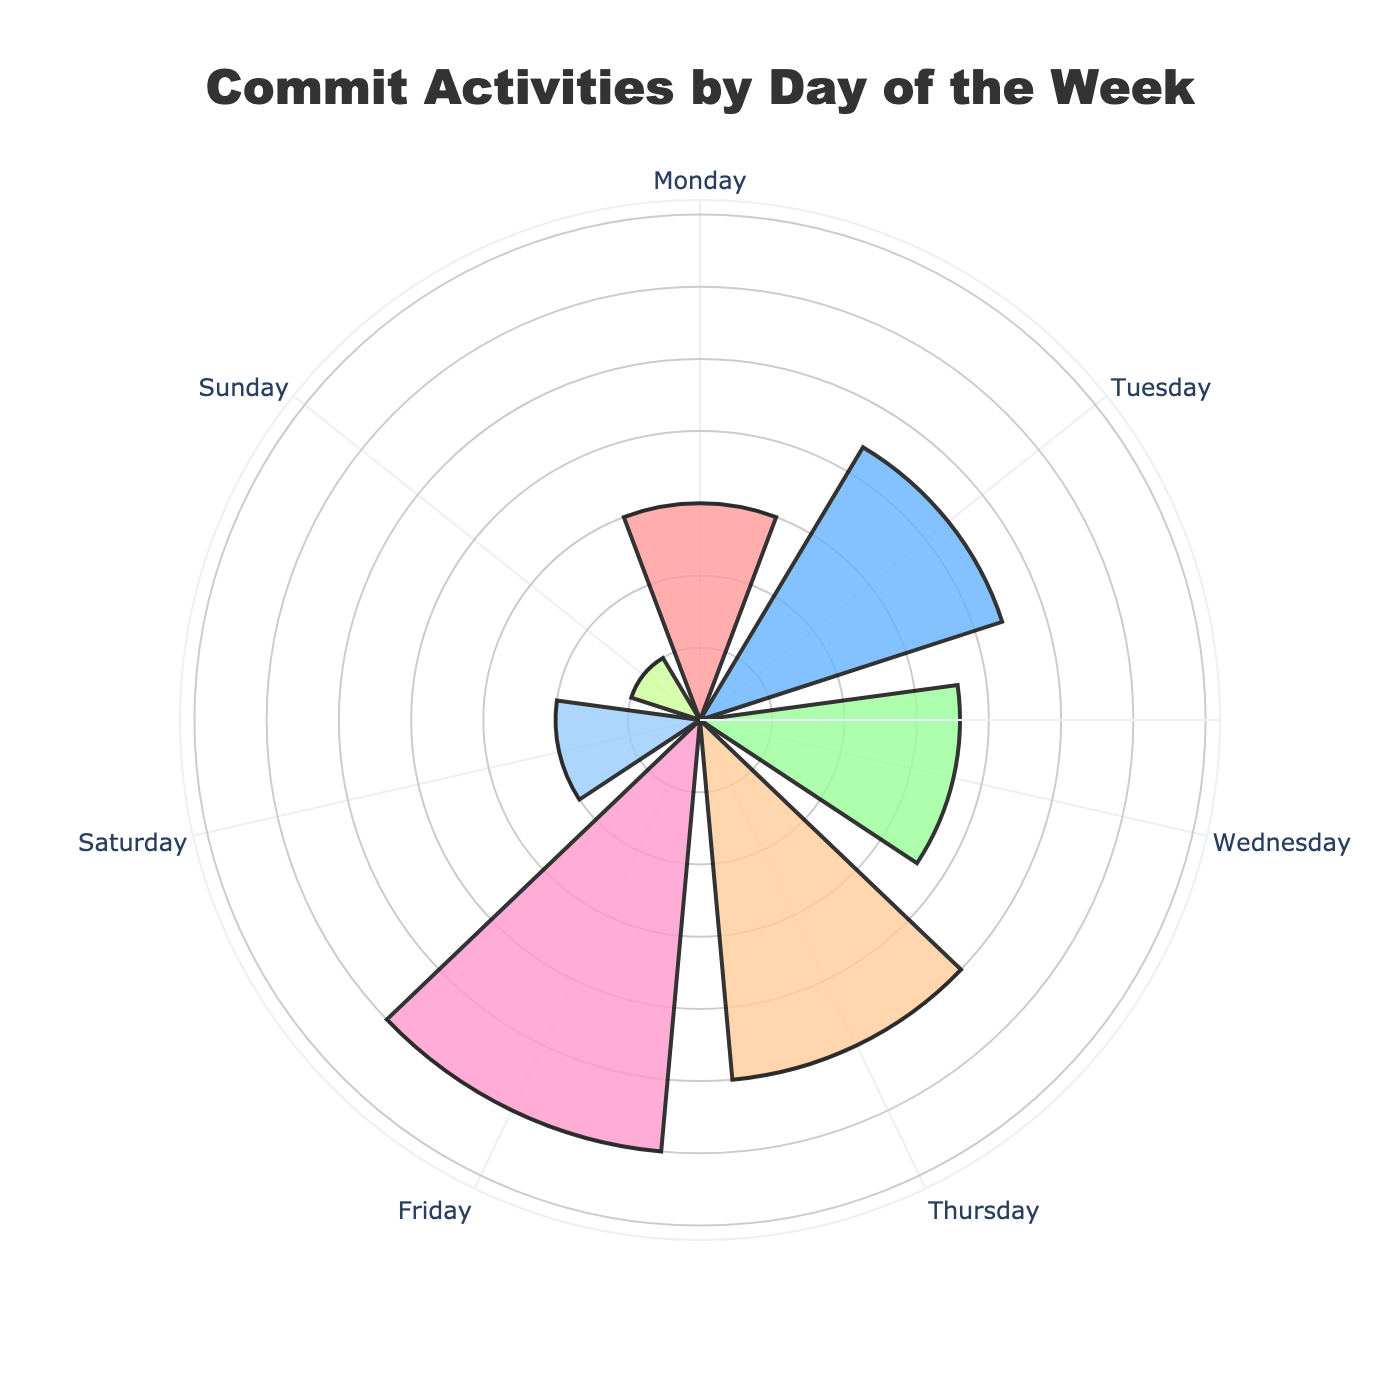What is the title of the chart? The title of the chart is displayed on top and reads "Commit Activities by Day of the Week."
Answer: Commit Activities by Day of the Week Which day has the highest number of commits? By observing the length of the bars, Friday has the highest number of commits.
Answer: Friday How many commits were made on Sunday? Sunday has a bar indicating 5 commits, which is noted next to the bar for Sunday.
Answer: 5 What is the combined number of commits for Monday and Tuesday? Monday has 15 commits, and Tuesday has 22 commits. Adding these values, 15 + 22 equals 37.
Answer: 37 Which days have fewer than 20 commits? By examining the lengths of the bars, Monday (15), Saturday (10), and Sunday (5) have fewer than 20 commits.
Answer: Monday, Saturday, Sunday How does the number of commits on Thursday compare to Saturday? Thursday has 25 commits, whereas Saturday has 10 commits. Thus, Thursday has more commits than Saturday.
Answer: Thursday has more commits What is the total number of commits for the entire week? Adding the number of commits for all days: 15 (Monday) + 22 (Tuesday) + 18 (Wednesday) + 25 (Thursday) + 30 (Friday) + 10 (Saturday) + 5 (Sunday) totals 125.
Answer: 125 What is the average number of commits per day? The total number of commits is 125. There are 7 days in a week. So, the average is 125 / 7, which is approximately 17.86.
Answer: 17.86 Which day has the second-highest number of commits? By comparing the heights of the bars, Friday has the most commits (30), and Thursday has the next highest number of commits with 25.
Answer: Thursday 